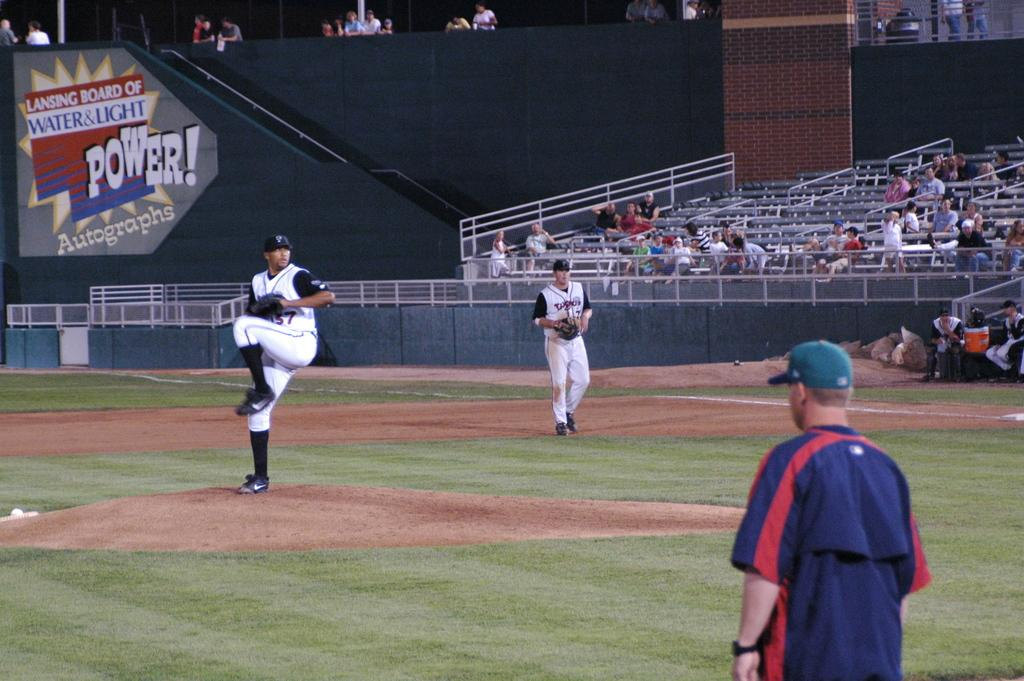<image>
Present a compact description of the photo's key features. A man is on the mound getting ready to pitch in a uniform with the number 37 on it. 